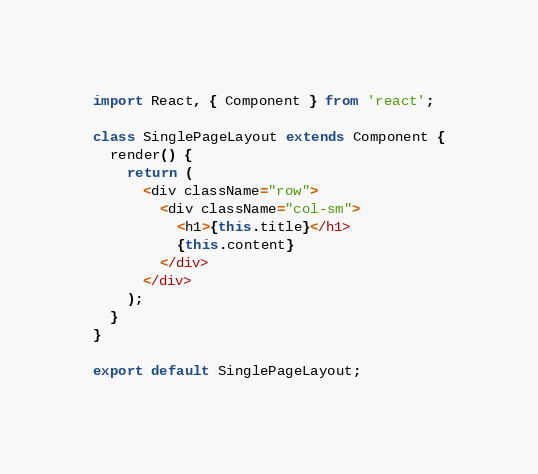Convert code to text. <code><loc_0><loc_0><loc_500><loc_500><_JavaScript_>import React, { Component } from 'react';

class SinglePageLayout extends Component {
  render() {
    return (
      <div className="row">
        <div className="col-sm">
          <h1>{this.title}</h1>
          {this.content}
        </div>
      </div>
    );
  }
}

export default SinglePageLayout;</code> 